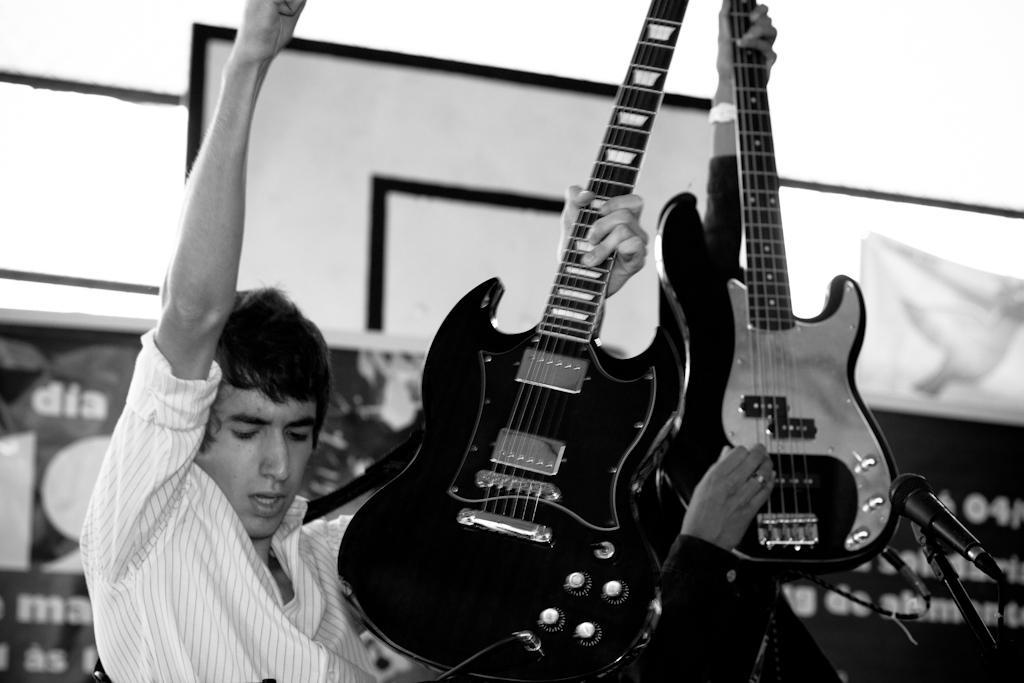What is the main subject of the image? The main subject of the image is a concert. What are the two persons in the center of the image doing? The two persons in the center of the image are playing guitars. Can you describe the equipment on the right side of the image? There is a microphone on the right side of the image. How many tents can be seen at the camp in the image? There is no camp or tents present in the image; it is a concert scene with two persons playing guitars and a microphone. 